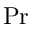<formula> <loc_0><loc_0><loc_500><loc_500>P r</formula> 